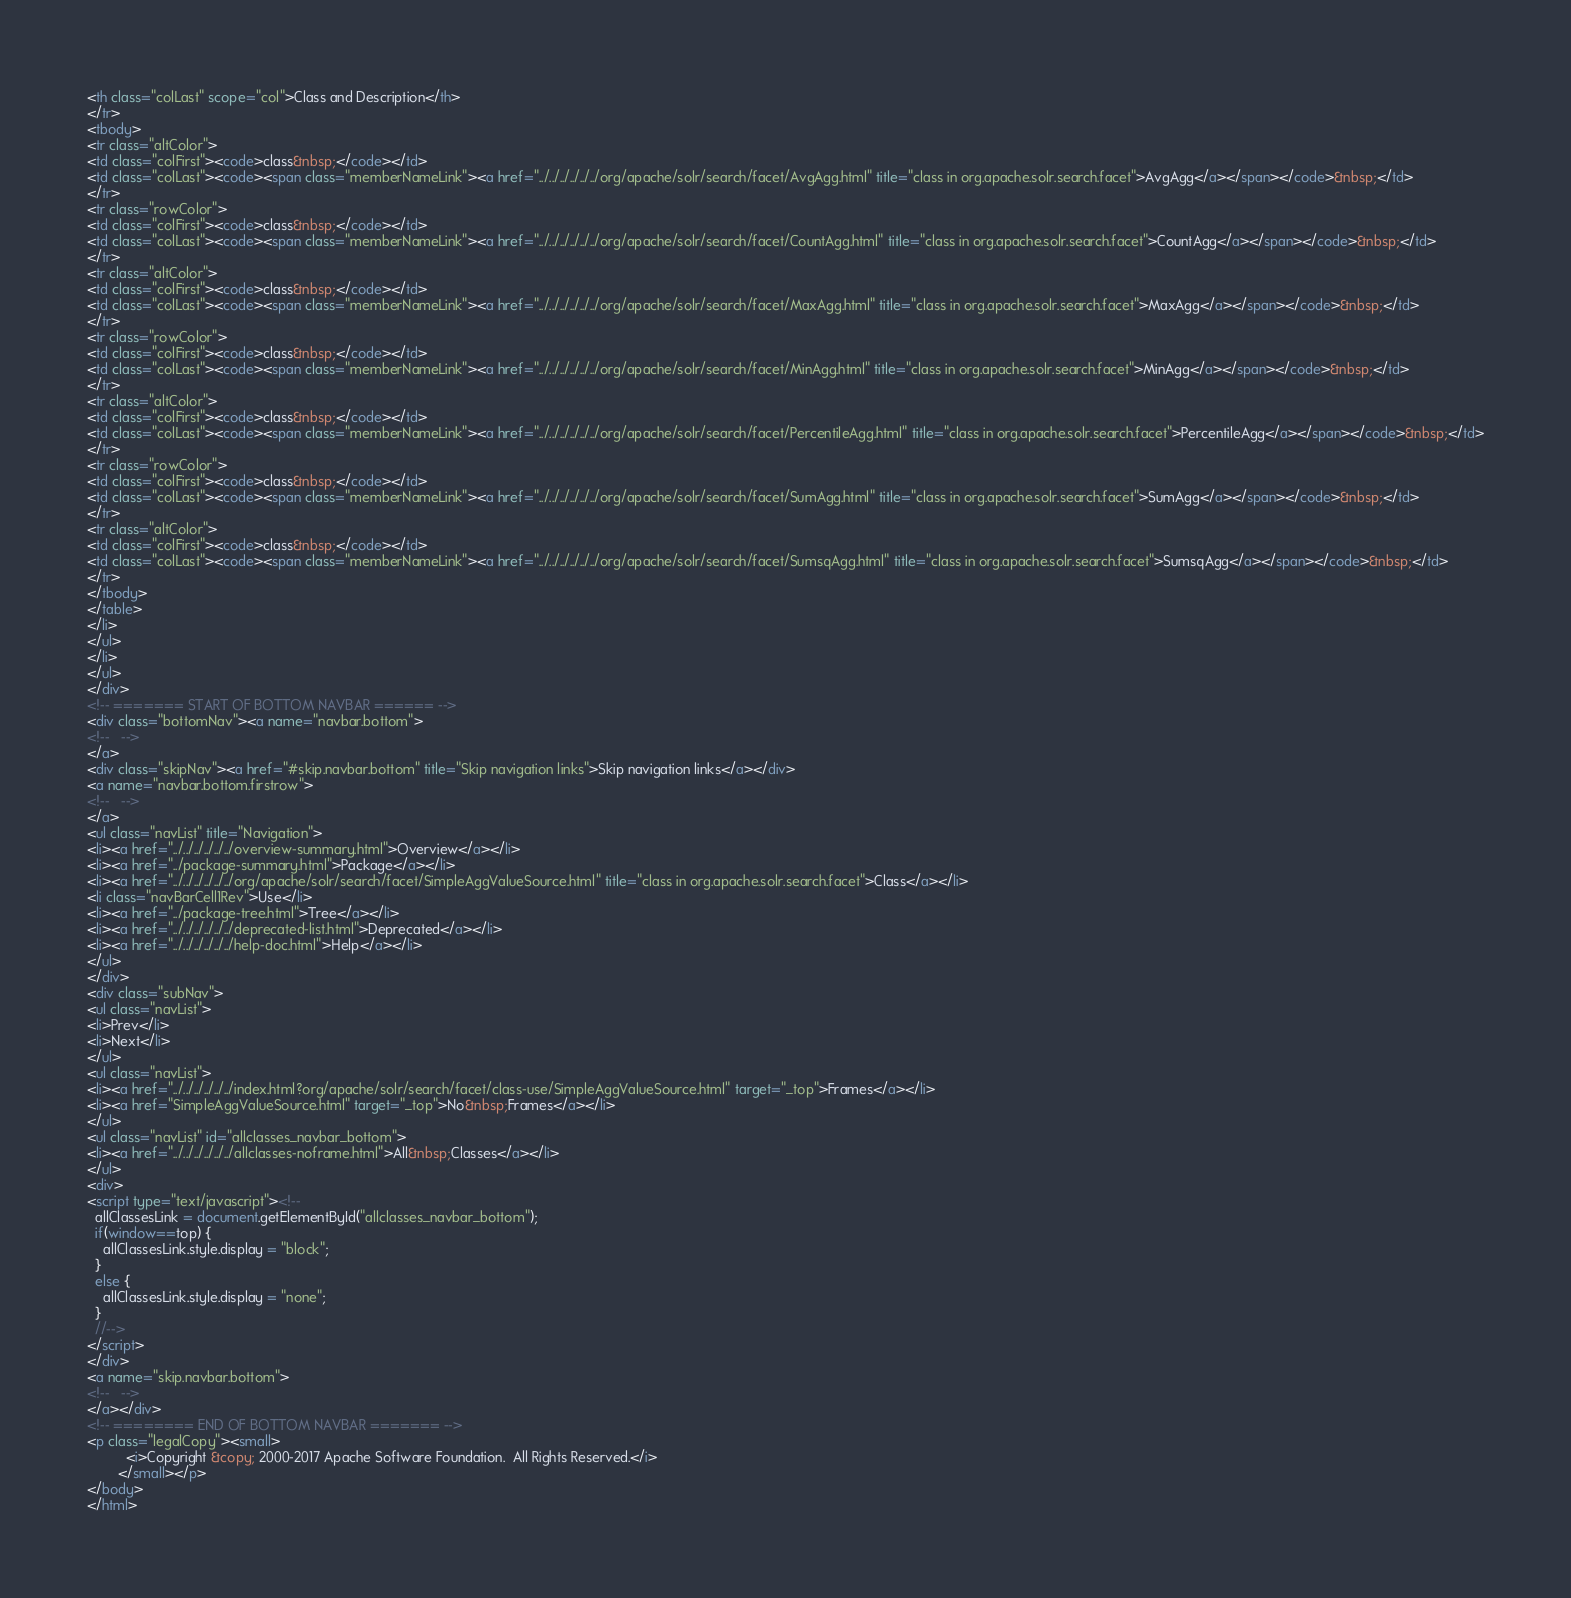Convert code to text. <code><loc_0><loc_0><loc_500><loc_500><_HTML_><th class="colLast" scope="col">Class and Description</th>
</tr>
<tbody>
<tr class="altColor">
<td class="colFirst"><code>class&nbsp;</code></td>
<td class="colLast"><code><span class="memberNameLink"><a href="../../../../../../org/apache/solr/search/facet/AvgAgg.html" title="class in org.apache.solr.search.facet">AvgAgg</a></span></code>&nbsp;</td>
</tr>
<tr class="rowColor">
<td class="colFirst"><code>class&nbsp;</code></td>
<td class="colLast"><code><span class="memberNameLink"><a href="../../../../../../org/apache/solr/search/facet/CountAgg.html" title="class in org.apache.solr.search.facet">CountAgg</a></span></code>&nbsp;</td>
</tr>
<tr class="altColor">
<td class="colFirst"><code>class&nbsp;</code></td>
<td class="colLast"><code><span class="memberNameLink"><a href="../../../../../../org/apache/solr/search/facet/MaxAgg.html" title="class in org.apache.solr.search.facet">MaxAgg</a></span></code>&nbsp;</td>
</tr>
<tr class="rowColor">
<td class="colFirst"><code>class&nbsp;</code></td>
<td class="colLast"><code><span class="memberNameLink"><a href="../../../../../../org/apache/solr/search/facet/MinAgg.html" title="class in org.apache.solr.search.facet">MinAgg</a></span></code>&nbsp;</td>
</tr>
<tr class="altColor">
<td class="colFirst"><code>class&nbsp;</code></td>
<td class="colLast"><code><span class="memberNameLink"><a href="../../../../../../org/apache/solr/search/facet/PercentileAgg.html" title="class in org.apache.solr.search.facet">PercentileAgg</a></span></code>&nbsp;</td>
</tr>
<tr class="rowColor">
<td class="colFirst"><code>class&nbsp;</code></td>
<td class="colLast"><code><span class="memberNameLink"><a href="../../../../../../org/apache/solr/search/facet/SumAgg.html" title="class in org.apache.solr.search.facet">SumAgg</a></span></code>&nbsp;</td>
</tr>
<tr class="altColor">
<td class="colFirst"><code>class&nbsp;</code></td>
<td class="colLast"><code><span class="memberNameLink"><a href="../../../../../../org/apache/solr/search/facet/SumsqAgg.html" title="class in org.apache.solr.search.facet">SumsqAgg</a></span></code>&nbsp;</td>
</tr>
</tbody>
</table>
</li>
</ul>
</li>
</ul>
</div>
<!-- ======= START OF BOTTOM NAVBAR ====== -->
<div class="bottomNav"><a name="navbar.bottom">
<!--   -->
</a>
<div class="skipNav"><a href="#skip.navbar.bottom" title="Skip navigation links">Skip navigation links</a></div>
<a name="navbar.bottom.firstrow">
<!--   -->
</a>
<ul class="navList" title="Navigation">
<li><a href="../../../../../../overview-summary.html">Overview</a></li>
<li><a href="../package-summary.html">Package</a></li>
<li><a href="../../../../../../org/apache/solr/search/facet/SimpleAggValueSource.html" title="class in org.apache.solr.search.facet">Class</a></li>
<li class="navBarCell1Rev">Use</li>
<li><a href="../package-tree.html">Tree</a></li>
<li><a href="../../../../../../deprecated-list.html">Deprecated</a></li>
<li><a href="../../../../../../help-doc.html">Help</a></li>
</ul>
</div>
<div class="subNav">
<ul class="navList">
<li>Prev</li>
<li>Next</li>
</ul>
<ul class="navList">
<li><a href="../../../../../../index.html?org/apache/solr/search/facet/class-use/SimpleAggValueSource.html" target="_top">Frames</a></li>
<li><a href="SimpleAggValueSource.html" target="_top">No&nbsp;Frames</a></li>
</ul>
<ul class="navList" id="allclasses_navbar_bottom">
<li><a href="../../../../../../allclasses-noframe.html">All&nbsp;Classes</a></li>
</ul>
<div>
<script type="text/javascript"><!--
  allClassesLink = document.getElementById("allclasses_navbar_bottom");
  if(window==top) {
    allClassesLink.style.display = "block";
  }
  else {
    allClassesLink.style.display = "none";
  }
  //-->
</script>
</div>
<a name="skip.navbar.bottom">
<!--   -->
</a></div>
<!-- ======== END OF BOTTOM NAVBAR ======= -->
<p class="legalCopy"><small>
          <i>Copyright &copy; 2000-2017 Apache Software Foundation.  All Rights Reserved.</i>
        </small></p>
</body>
</html>
</code> 